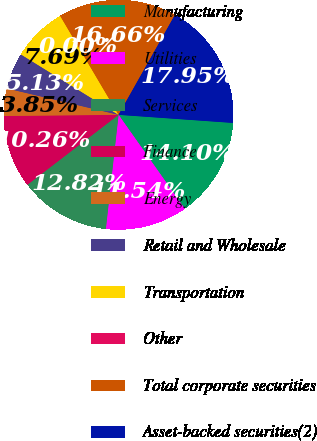Convert chart. <chart><loc_0><loc_0><loc_500><loc_500><pie_chart><fcel>Manufacturing<fcel>Utilities<fcel>Services<fcel>Finance<fcel>Energy<fcel>Retail and Wholesale<fcel>Transportation<fcel>Other<fcel>Total corporate securities<fcel>Asset-backed securities(2)<nl><fcel>14.1%<fcel>11.54%<fcel>12.82%<fcel>10.26%<fcel>3.85%<fcel>5.13%<fcel>7.69%<fcel>0.0%<fcel>16.66%<fcel>17.95%<nl></chart> 